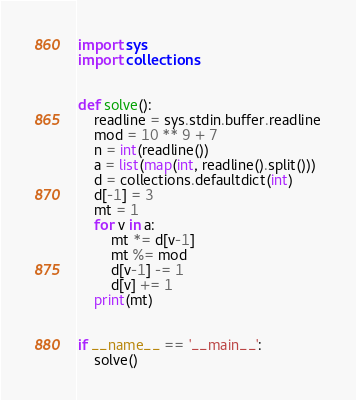Convert code to text. <code><loc_0><loc_0><loc_500><loc_500><_Python_>import sys
import collections


def solve():
    readline = sys.stdin.buffer.readline
    mod = 10 ** 9 + 7
    n = int(readline())
    a = list(map(int, readline().split()))
    d = collections.defaultdict(int)
    d[-1] = 3
    mt = 1
    for v in a:
        mt *= d[v-1]
        mt %= mod
        d[v-1] -= 1
        d[v] += 1
    print(mt)


if __name__ == '__main__':
    solve()
</code> 